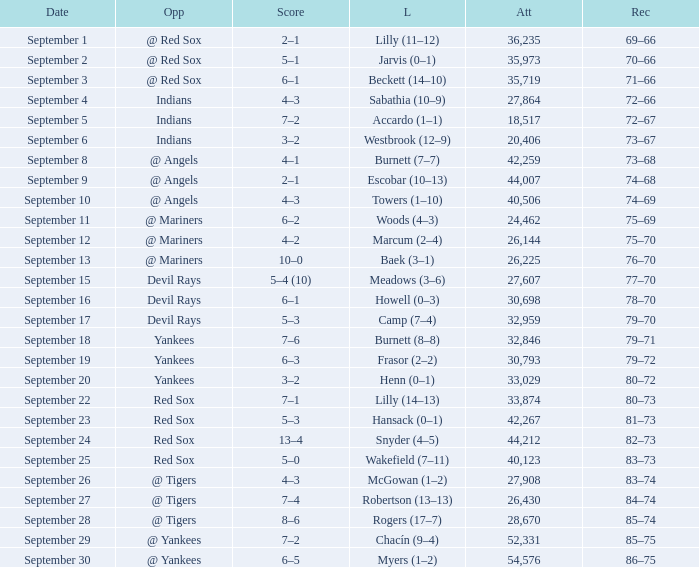Which opponent plays on September 19? Yankees. 